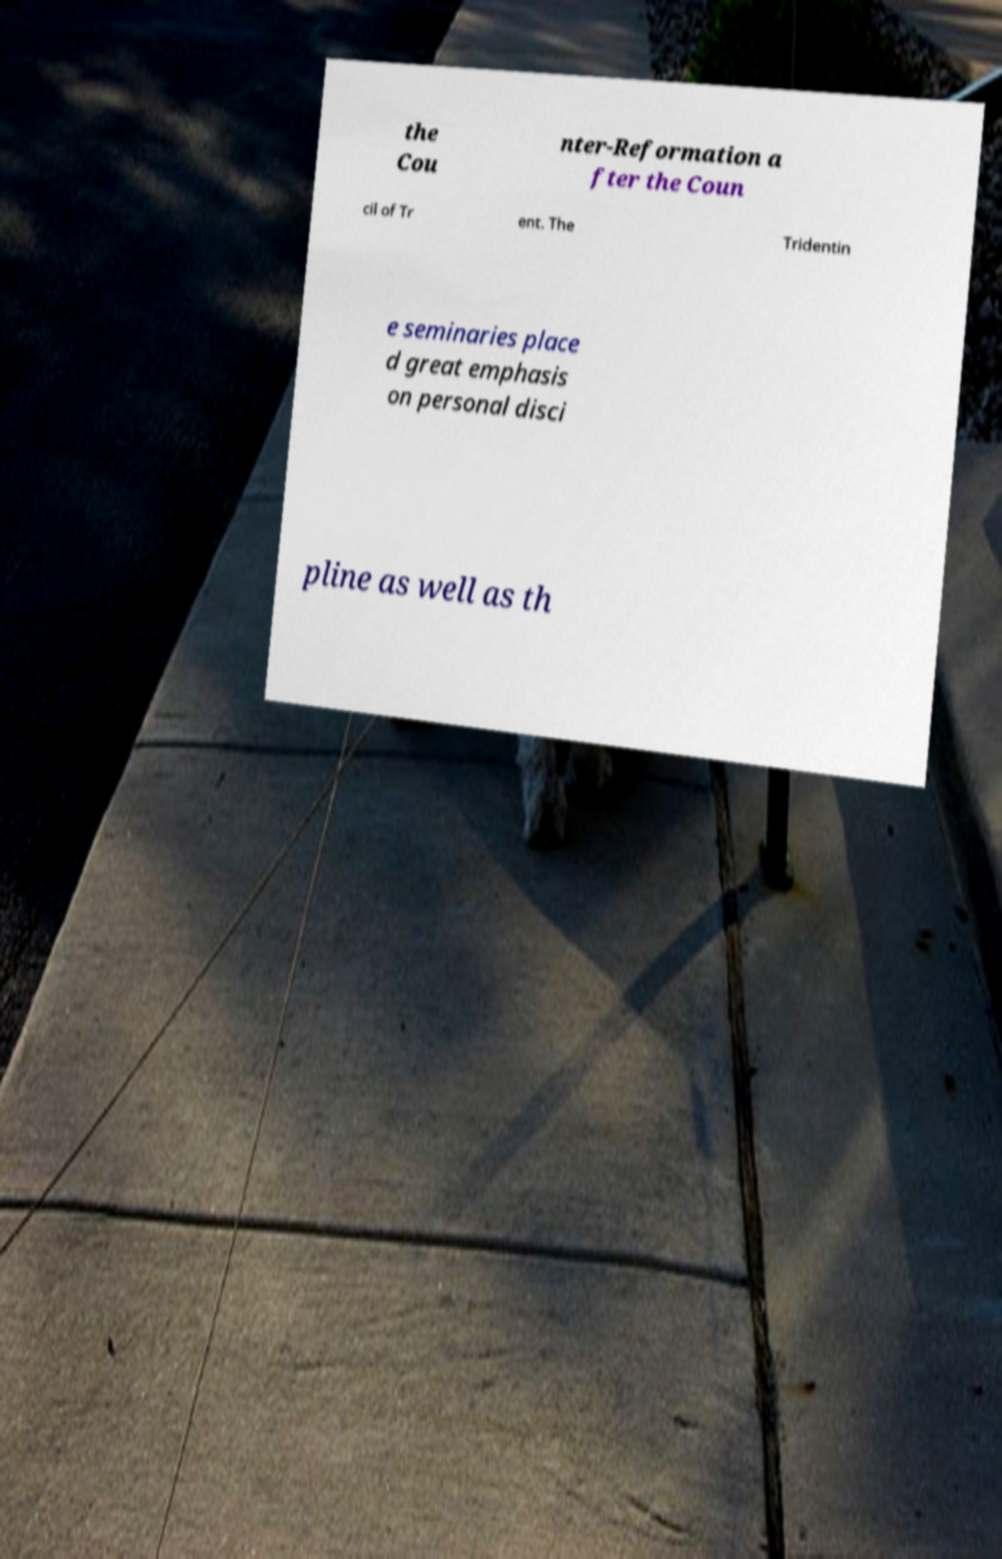I need the written content from this picture converted into text. Can you do that? the Cou nter-Reformation a fter the Coun cil of Tr ent. The Tridentin e seminaries place d great emphasis on personal disci pline as well as th 